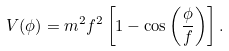<formula> <loc_0><loc_0><loc_500><loc_500>V ( \phi ) = m ^ { 2 } f ^ { 2 } \left [ 1 - \cos \left ( \frac { \phi } { f } \right ) \right ] .</formula> 